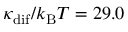Convert formula to latex. <formula><loc_0><loc_0><loc_500><loc_500>\kappa _ { d i f } / k _ { B } T = 2 9 . 0</formula> 